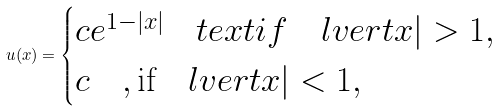Convert formula to latex. <formula><loc_0><loc_0><loc_500><loc_500>u ( x ) = \begin{cases} c e ^ { 1 - | x | } \quad t e x t { i f } \quad l v e r t x | > 1 , \\ c \quad , \text {if} \quad l v e r t x | < 1 , \end{cases}</formula> 